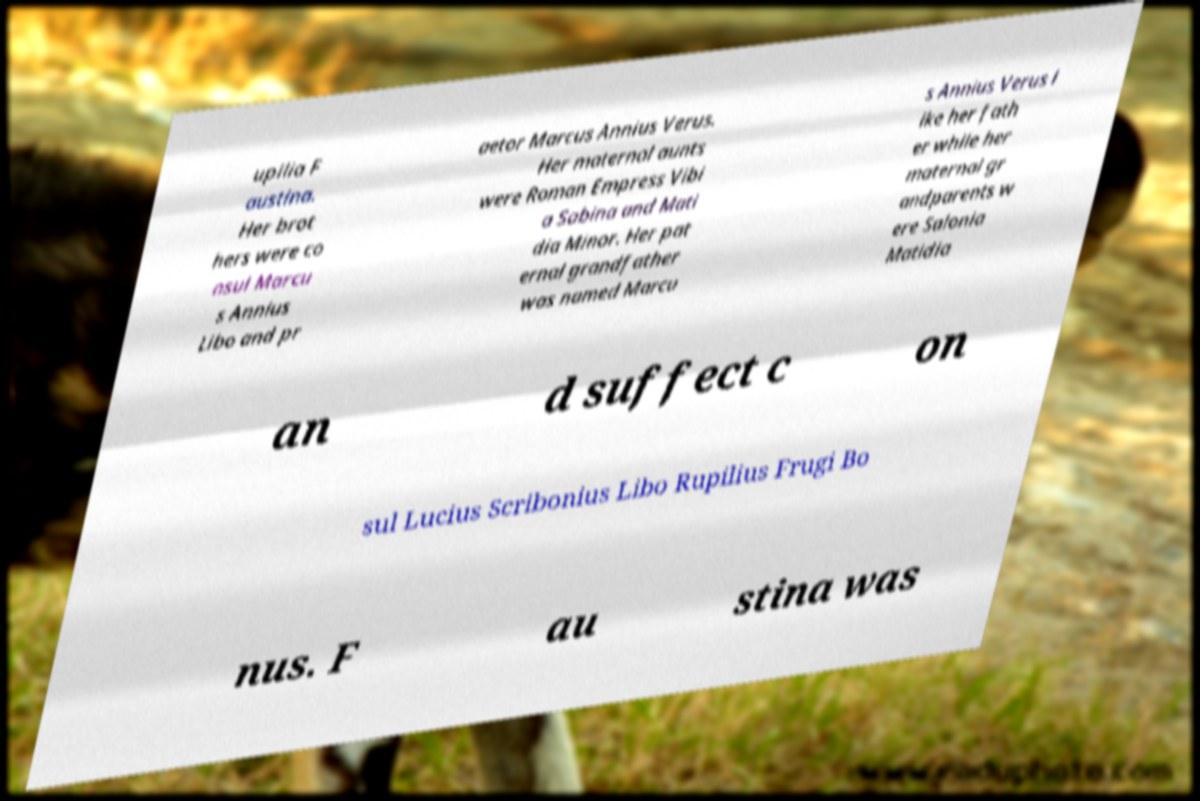There's text embedded in this image that I need extracted. Can you transcribe it verbatim? upilia F austina. Her brot hers were co nsul Marcu s Annius Libo and pr aetor Marcus Annius Verus. Her maternal aunts were Roman Empress Vibi a Sabina and Mati dia Minor. Her pat ernal grandfather was named Marcu s Annius Verus l ike her fath er while her maternal gr andparents w ere Salonia Matidia an d suffect c on sul Lucius Scribonius Libo Rupilius Frugi Bo nus. F au stina was 